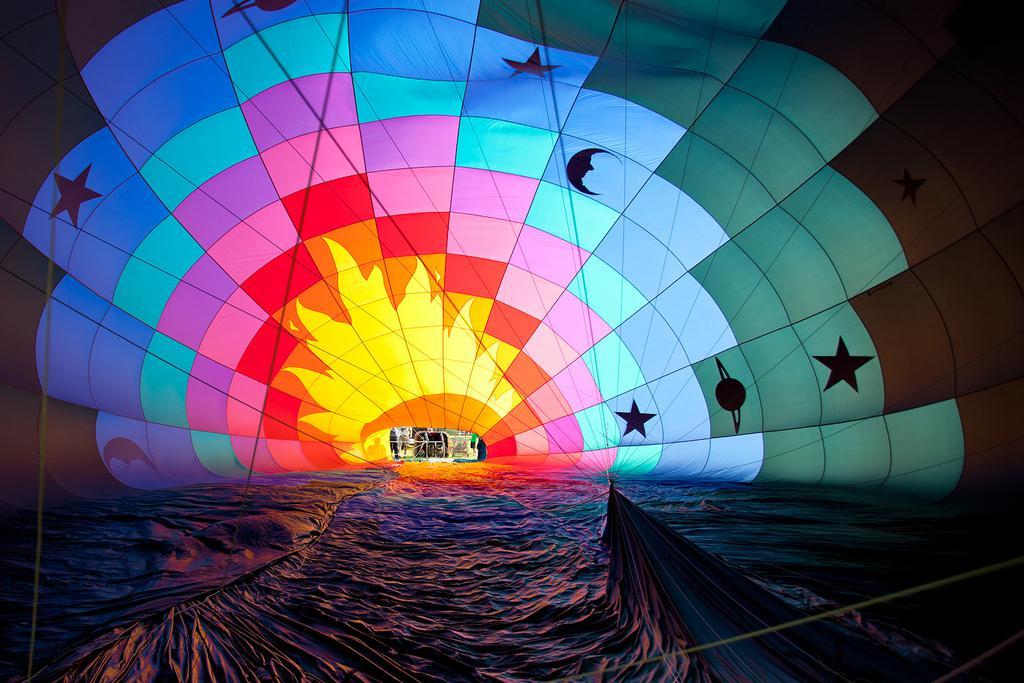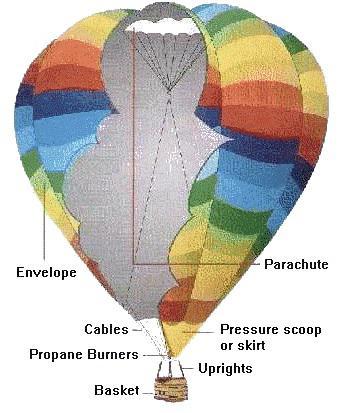The first image is the image on the left, the second image is the image on the right. Assess this claim about the two images: "An image shows the interior of a balloon which is lying on the ground.". Correct or not? Answer yes or no. Yes. The first image is the image on the left, the second image is the image on the right. Considering the images on both sides, is "One image shows a single balloon in midair with people in its basket and a view of the landscape under it including green areas." valid? Answer yes or no. No. 